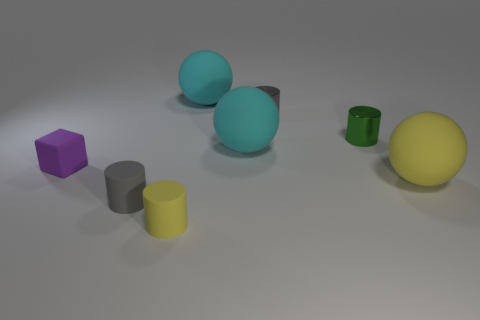There is a gray matte thing that is the same size as the green cylinder; what shape is it?
Offer a terse response. Cylinder. What size is the cyan matte sphere behind the tiny green metallic thing to the right of the block?
Provide a short and direct response. Large. Are the gray cylinder that is to the right of the gray matte cylinder and the small yellow thing made of the same material?
Offer a very short reply. No. The large thing that is in front of the purple cube has what shape?
Offer a very short reply. Sphere. How many yellow rubber spheres are the same size as the purple thing?
Offer a very short reply. 0. What size is the green metal object?
Your answer should be compact. Small. What number of tiny purple cubes are on the right side of the rubber cube?
Make the answer very short. 0. What shape is the small yellow thing that is the same material as the purple cube?
Offer a very short reply. Cylinder. Are there fewer cyan rubber balls that are behind the small yellow thing than yellow matte cylinders that are behind the block?
Your response must be concise. No. Are there more cyan matte spheres than brown rubber spheres?
Your answer should be very brief. Yes. 